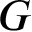<formula> <loc_0><loc_0><loc_500><loc_500>G</formula> 